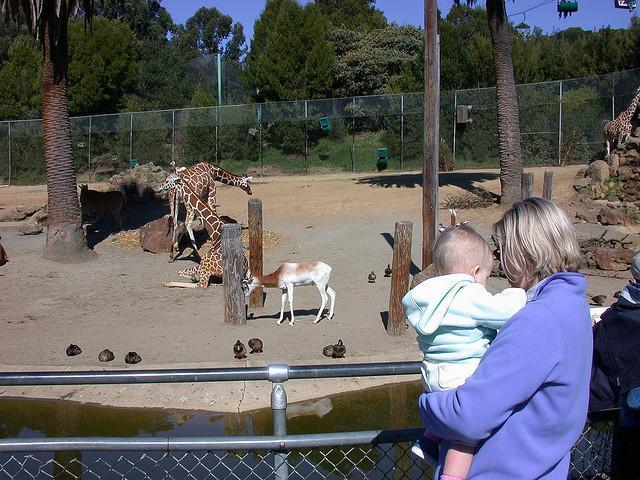How many giraffes are there?
Give a very brief answer. 2. How many people are there?
Give a very brief answer. 3. How many wheels does the skateboard have?
Give a very brief answer. 0. 